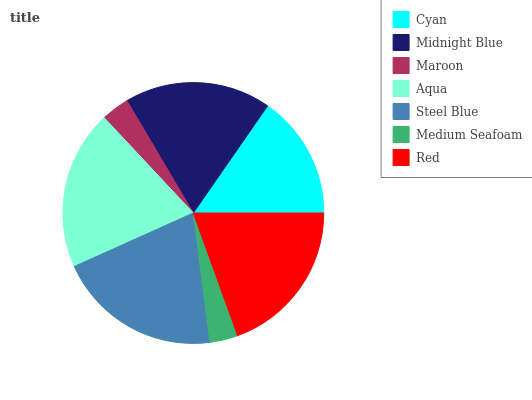Is Medium Seafoam the minimum?
Answer yes or no. Yes. Is Steel Blue the maximum?
Answer yes or no. Yes. Is Midnight Blue the minimum?
Answer yes or no. No. Is Midnight Blue the maximum?
Answer yes or no. No. Is Midnight Blue greater than Cyan?
Answer yes or no. Yes. Is Cyan less than Midnight Blue?
Answer yes or no. Yes. Is Cyan greater than Midnight Blue?
Answer yes or no. No. Is Midnight Blue less than Cyan?
Answer yes or no. No. Is Midnight Blue the high median?
Answer yes or no. Yes. Is Midnight Blue the low median?
Answer yes or no. Yes. Is Steel Blue the high median?
Answer yes or no. No. Is Red the low median?
Answer yes or no. No. 